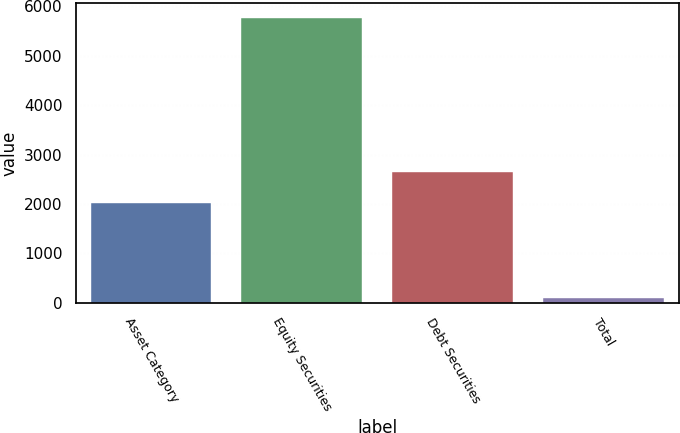Convert chart to OTSL. <chart><loc_0><loc_0><loc_500><loc_500><bar_chart><fcel>Asset Category<fcel>Equity Securities<fcel>Debt Securities<fcel>Total<nl><fcel>2017<fcel>5773<fcel>2644<fcel>100<nl></chart> 